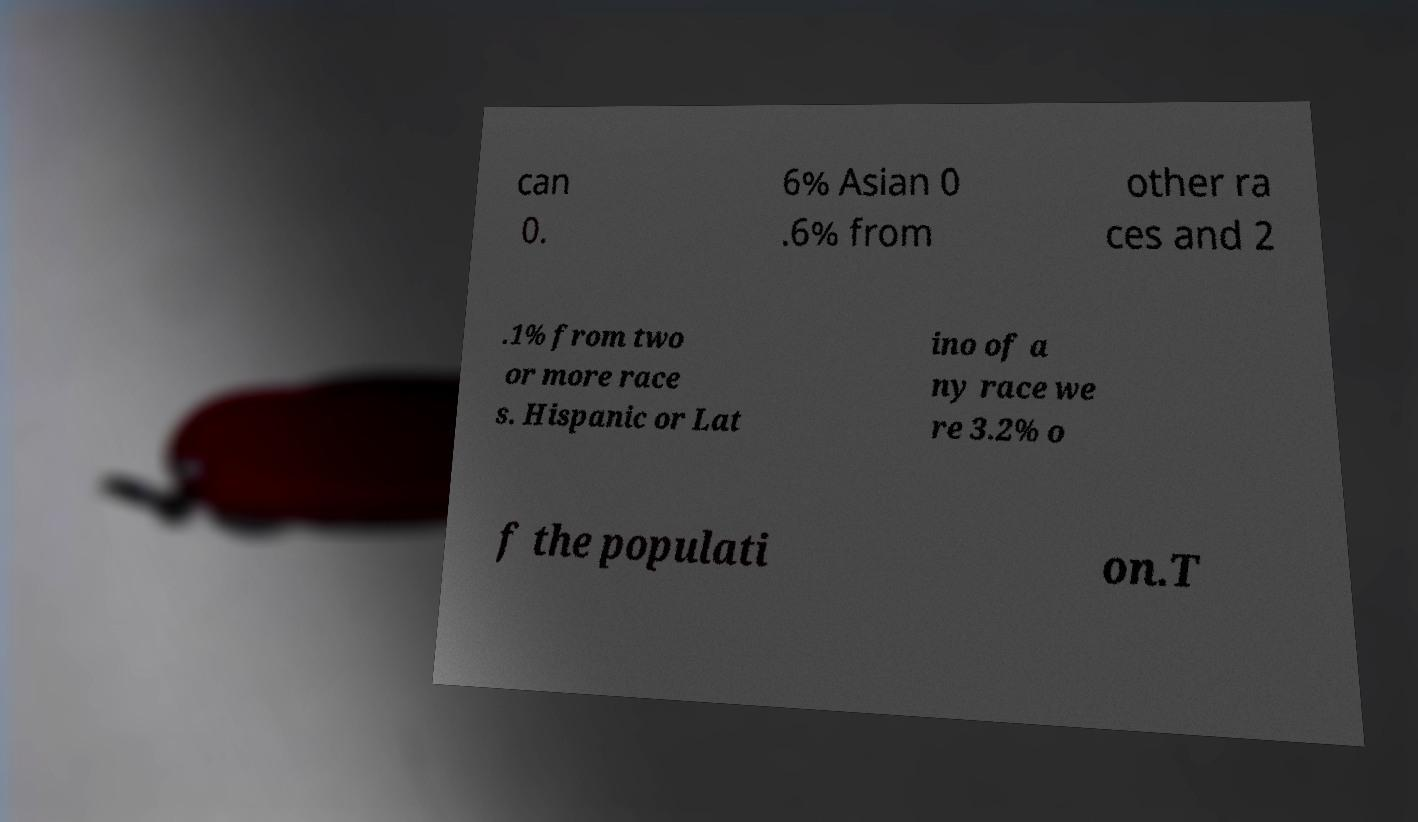Please identify and transcribe the text found in this image. can 0. 6% Asian 0 .6% from other ra ces and 2 .1% from two or more race s. Hispanic or Lat ino of a ny race we re 3.2% o f the populati on.T 